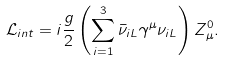<formula> <loc_0><loc_0><loc_500><loc_500>\mathcal { L } _ { i n t } = i { \frac { g } { 2 } } \left ( \sum _ { i = 1 } ^ { 3 } \bar { \nu } _ { i L } \gamma ^ { \mu } \nu _ { i L } \right ) Z _ { \mu } ^ { 0 } .</formula> 